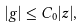Convert formula to latex. <formula><loc_0><loc_0><loc_500><loc_500>| g | \leq C _ { 0 } | z | ,</formula> 